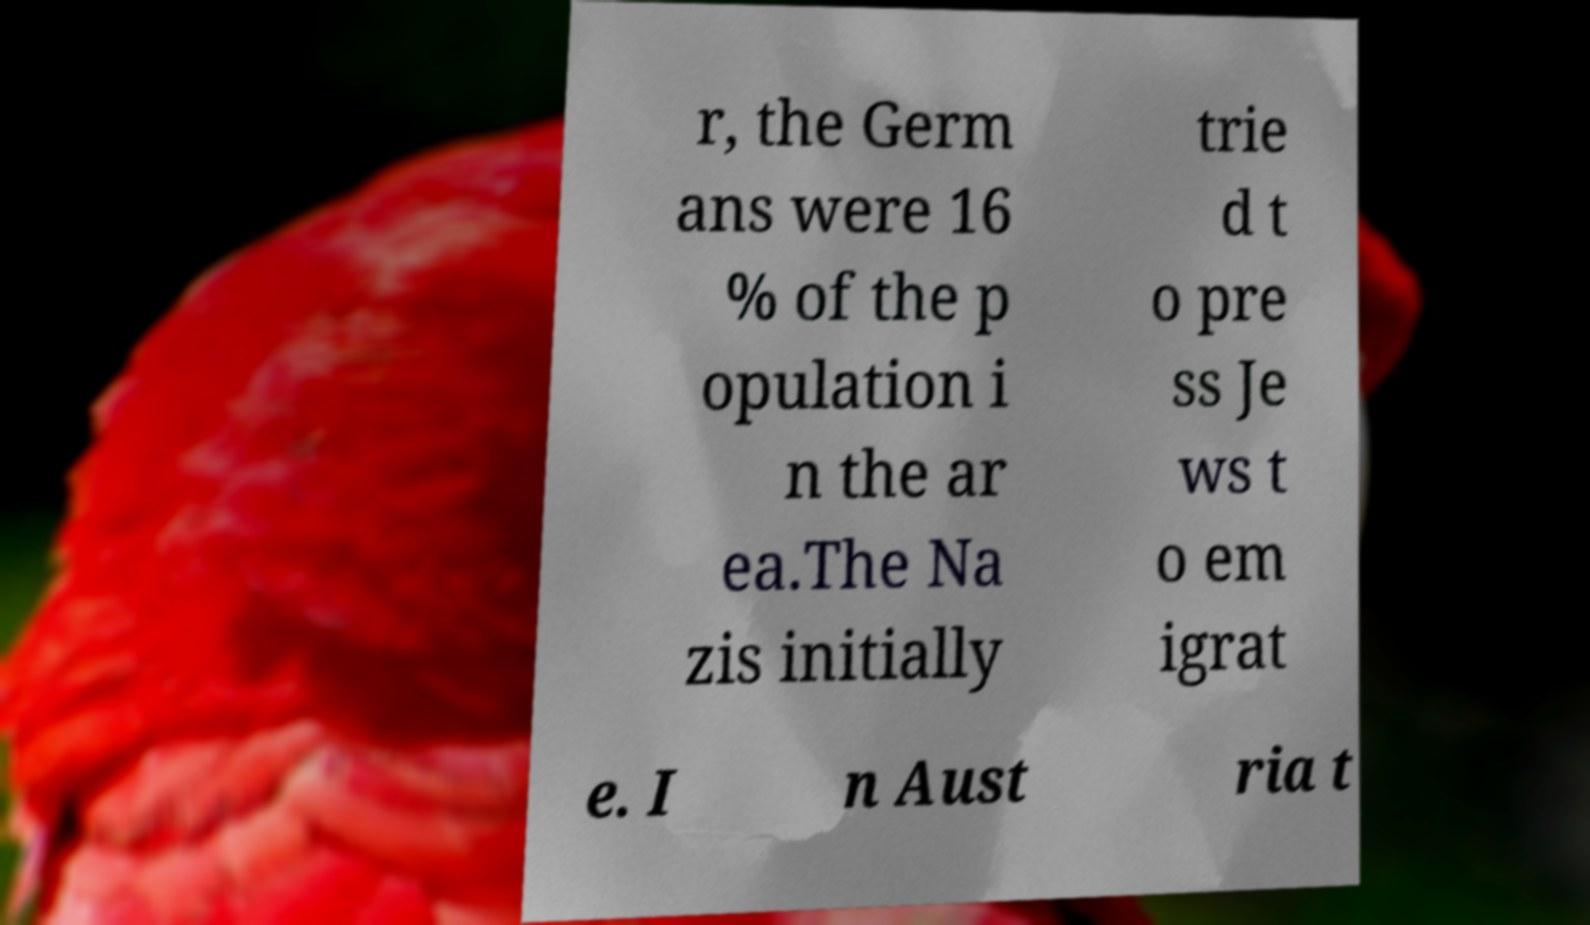For documentation purposes, I need the text within this image transcribed. Could you provide that? r, the Germ ans were 16 % of the p opulation i n the ar ea.The Na zis initially trie d t o pre ss Je ws t o em igrat e. I n Aust ria t 